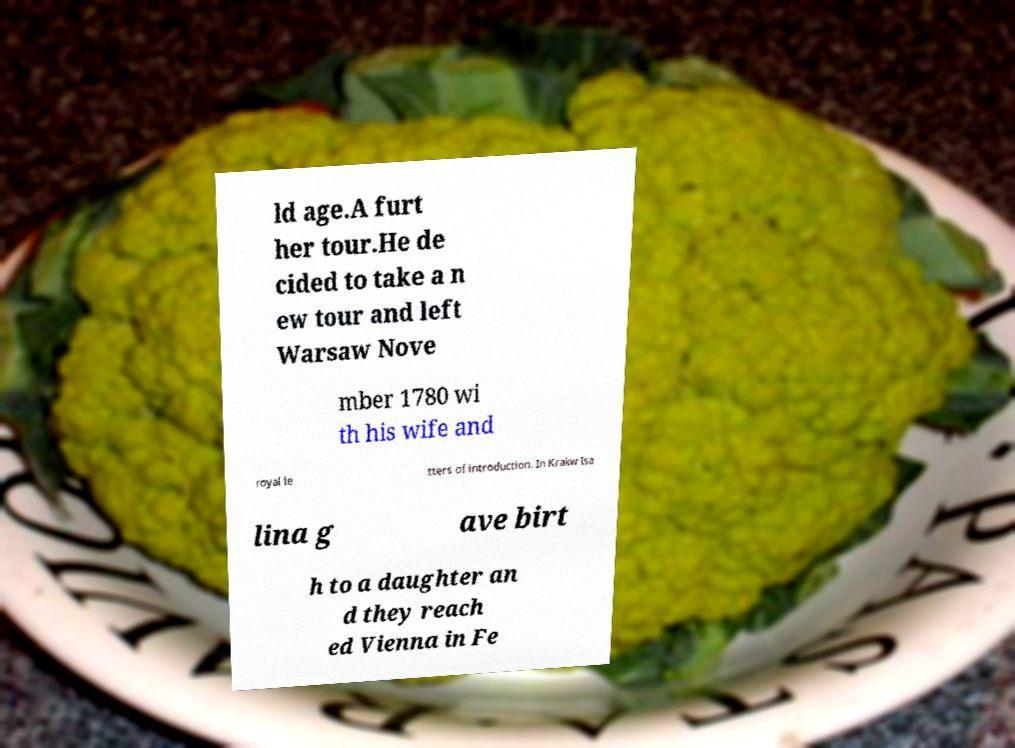For documentation purposes, I need the text within this image transcribed. Could you provide that? ld age.A furt her tour.He de cided to take a n ew tour and left Warsaw Nove mber 1780 wi th his wife and royal le tters of introduction. In Krakw Isa lina g ave birt h to a daughter an d they reach ed Vienna in Fe 